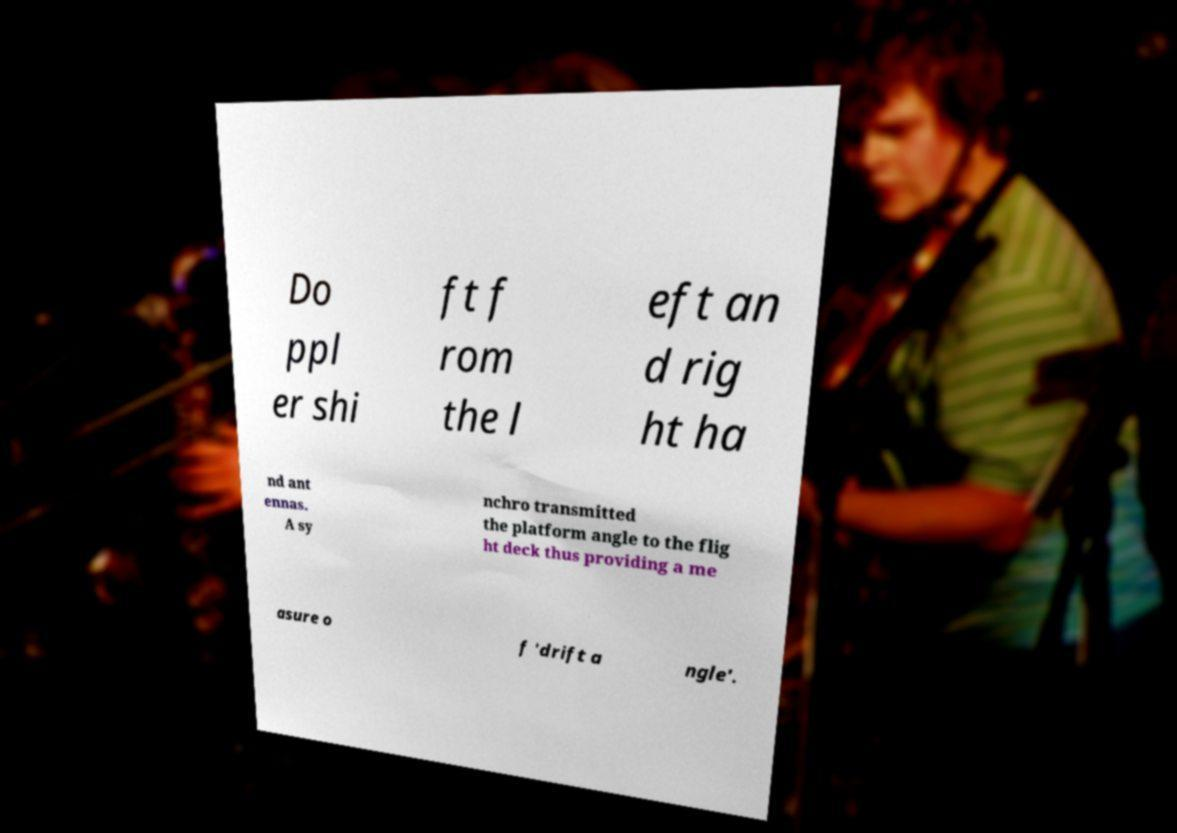Could you assist in decoding the text presented in this image and type it out clearly? Do ppl er shi ft f rom the l eft an d rig ht ha nd ant ennas. A sy nchro transmitted the platform angle to the flig ht deck thus providing a me asure o f 'drift a ngle'. 